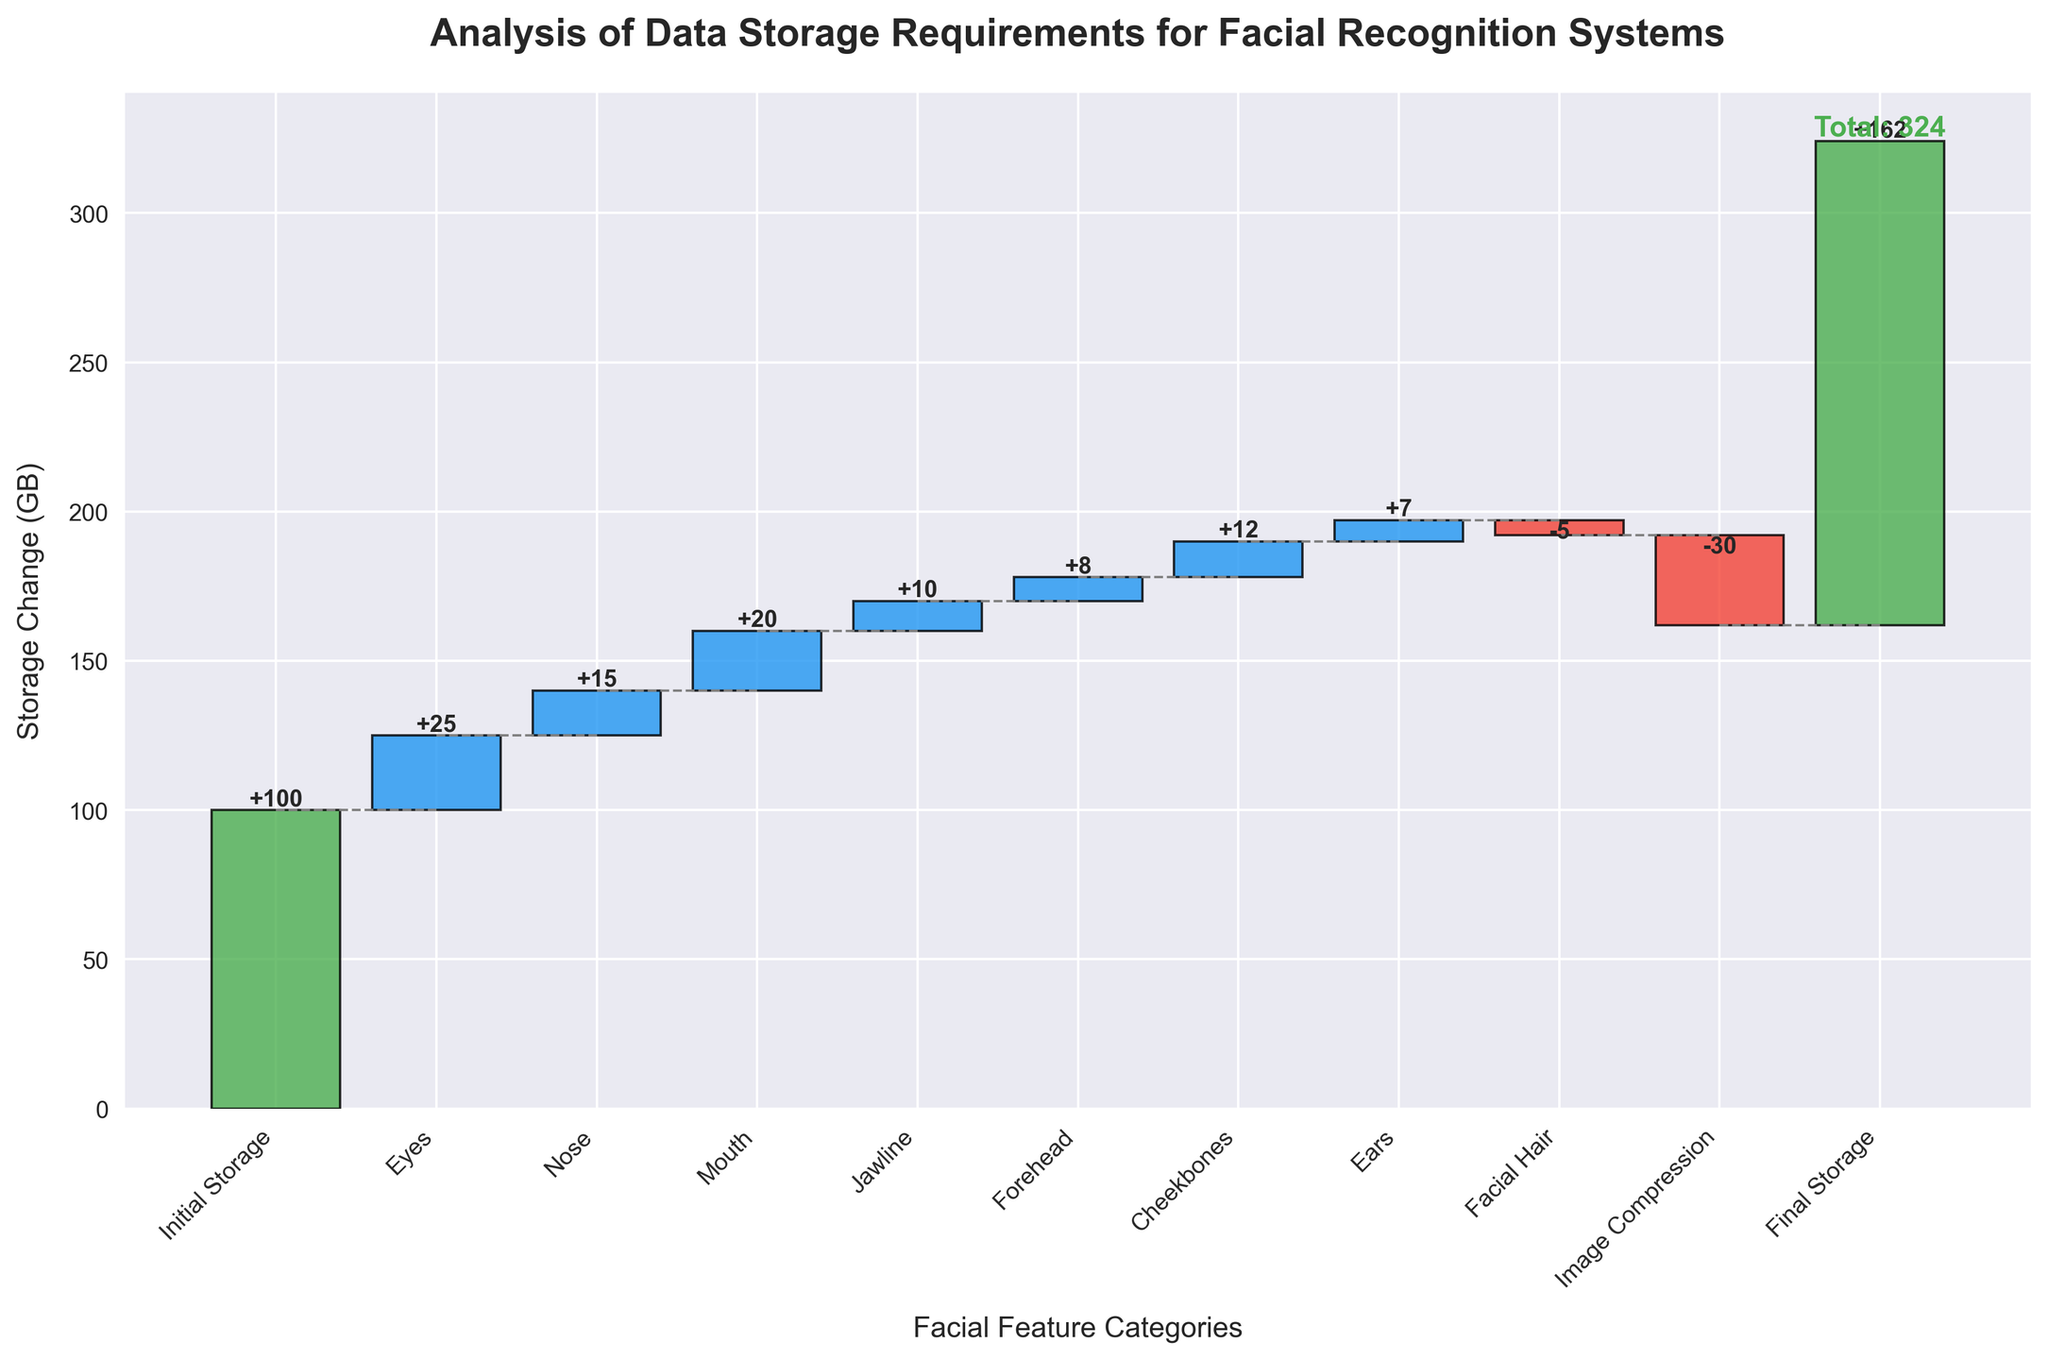What is the title of the chart? The title of the chart is found at the top of the figure. It reads "Analysis of Data Storage Requirements for Facial Recognition Systems."
Answer: Analysis of Data Storage Requirements for Facial Recognition Systems How many categories are analyzed in the figure? By counting the labels along the x-axis, you can see that there are 11 categories from "Initial Storage" to "Final Storage."
Answer: 11 Which category contributes the most to data storage requirements? Identify the bar with the largest positive value which is "Eyes" at +25 GB.
Answer: Eyes What is the total reduction in storage due to image compression? The value associated with "Image Compression" indicates a reduction of -30 GB.
Answer: 30 GB Which category has a negative contribution to the storage requirements, and how much is the reduction? The "Facial Hair" category has a negative contribution, marked by a red bar at -5 GB.
Answer: Facial Hair, 5 GB What is the cumulative storage requirement after accounting for the nose? Add up the initial storage (100 GB) and eyes (25 GB), then add the nose (15 GB) giving a cumulative storage of 140 GB.
Answer: 140 GB What is the final storage requirement in the system? The value associated with "Final Storage" at the end of the x-axis is 162 GB.
Answer: 162 GB Which categories have a storage increment of less than 10 GB? By examining the categorized values, "Jawline" (+10 GB), "Forehead" (+8 GB), "Cheekbones" (+12 GB), and "Ears" (+7 GB) are the increments below 10 GB.
Answer: Forehead, Ears What is the net storage change due to facial hair and image compression? Add the contributions of facial hair (-5 GB) and image compression (-30 GB), leading to a net change of -35 GB.
Answer: -35 GB How does the contribution of ears compare to the contribution of cheekbones? "Ears" contribute +7 GB while "Cheekbones" contribute +12 GB. Therefore, cheekbones contribute +5 GB more than ears.
Answer: Cheekbones contribute more by 5 GB 